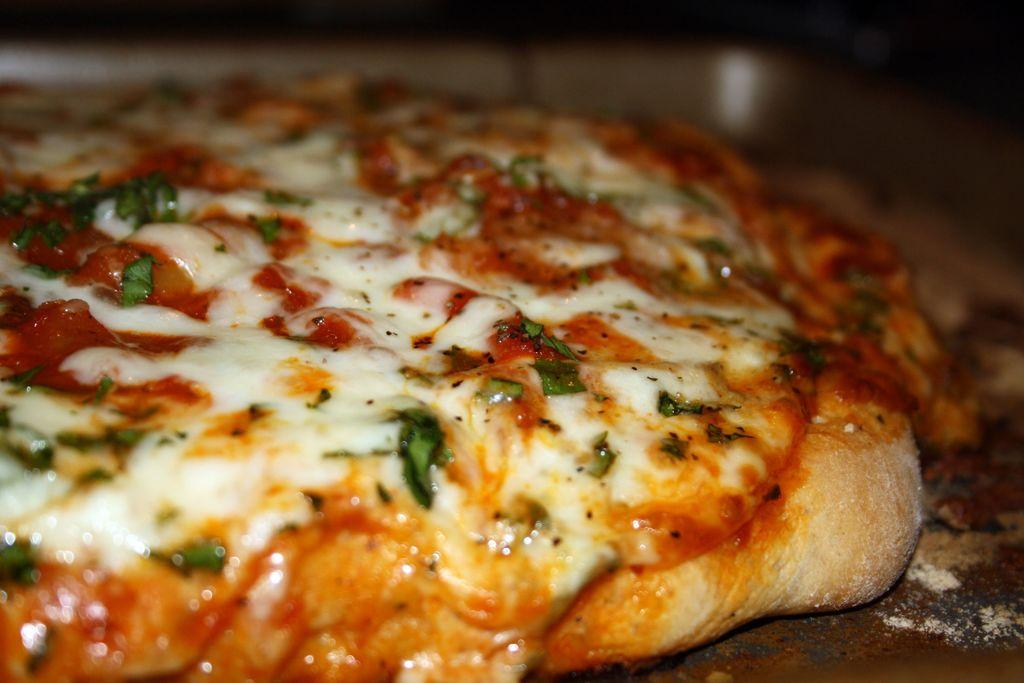What colors can be seen in the food in the image? The food in the image has white, green, red, and brown colors. What is the color of the surface on which the food is placed? The food is on a brown surface. What type of cave can be seen in the background of the image? There is no cave present in the image; it only features food on a brown surface. 